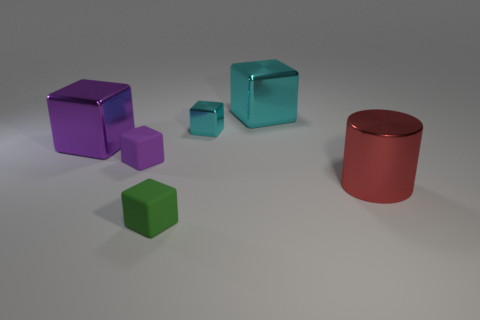The purple cube that is made of the same material as the big red thing is what size?
Offer a terse response. Large. Does the purple metal cube have the same size as the purple rubber object?
Your answer should be very brief. No. Are there any big cyan objects?
Provide a succinct answer. Yes. The metal cube that is the same color as the small shiny object is what size?
Give a very brief answer. Large. There is a matte cube in front of the large metallic thing that is right of the large block on the right side of the tiny green rubber object; how big is it?
Your response must be concise. Small. How many cyan things have the same material as the red thing?
Your answer should be very brief. 2. How many metal cubes have the same size as the purple matte object?
Offer a terse response. 1. The purple object in front of the large block on the left side of the purple thing that is in front of the big purple shiny object is made of what material?
Give a very brief answer. Rubber. How many things are either big metal spheres or tiny green objects?
Offer a very short reply. 1. Is there any other thing that is made of the same material as the tiny cyan cube?
Keep it short and to the point. Yes. 